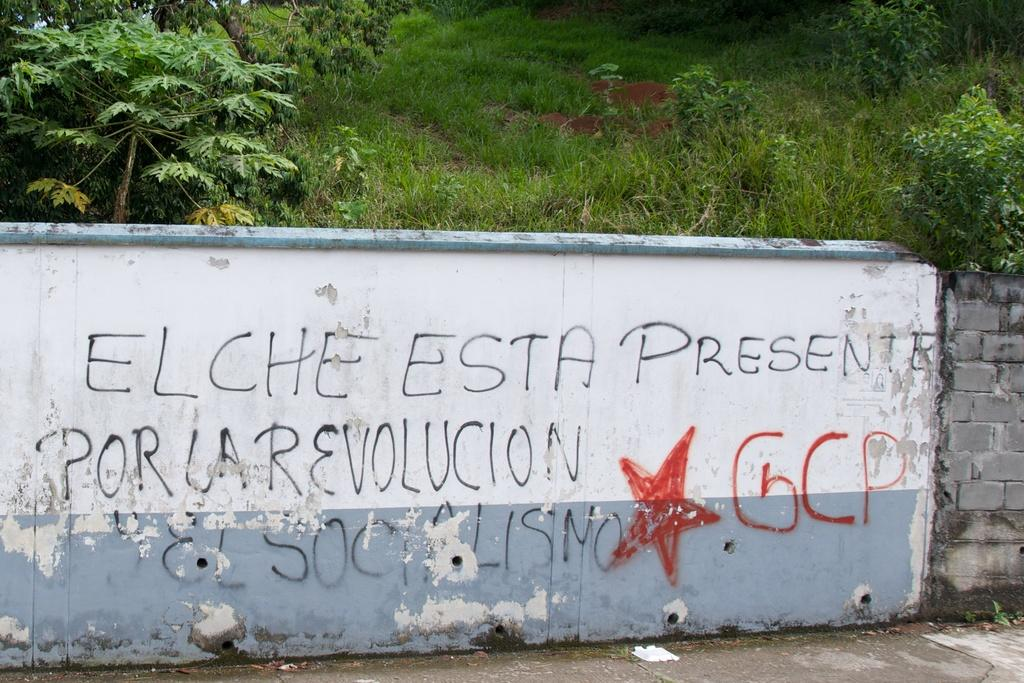What is the main feature in the image? There is a wall in the image. What colors are used on the wall? The wall has a white and blue color. Is there any text or writing on the wall? Yes, there is writing on the wall. What can be seen in the background of the image? Trees and green grass are visible in the background. Can you see a giraffe eating cheese in the image? No, there is no giraffe or cheese present in the image. 